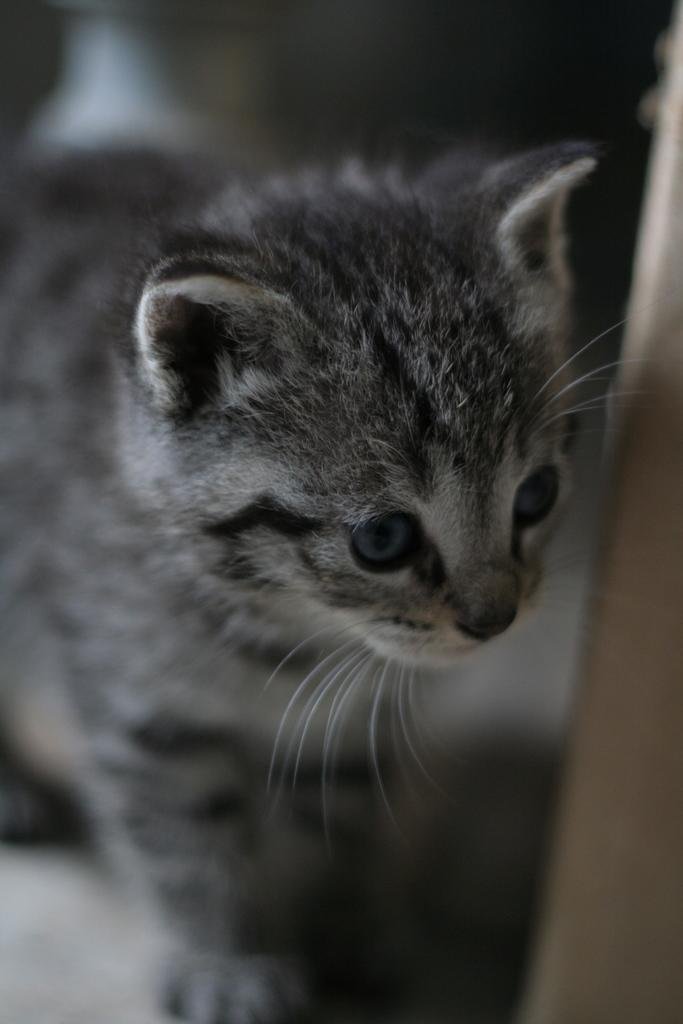What type of animal is present in the image? There is a cat in the image. What type of soda is the cat drinking in the image? There is no soda present in the image; it features a cat. Is the cat eating a pear in the image? There is no pear present in the image; it features a cat. 